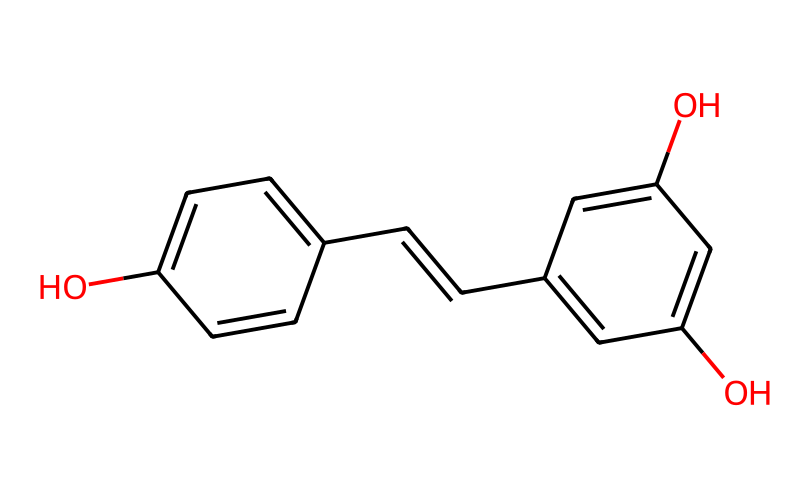What is the chemical name of this compound? The provided SMILES represents a compound known as resveratrol. The first part ("Oc1ccc") indicates the presence of a hydroxyl group (OH), which is characteristic of phenolic compounds like resveratrol.
Answer: resveratrol How many carbon atoms are there in this structure? Analyzing the SMILES, we can count the carbon atoms from the aromatic rings and the alkene chain structure. The first ring contributes six, the second contributes six, and the alkene linkage adds two more carbon atoms, totaling fourteen.
Answer: fourteen What functional groups are present in resveratrol? The SMILES shows two hydroxyl (–OH) groups attached to the aromatic rings, which are phenolic groups. The presence of a double bond (C=C) between two carbon atoms also indicates an alkene functional group.
Answer: hydroxyl and alkene How many rings are there in the molecular structure? The SMILES indicates two aromatic rings (indicated by the "c" in the structure). The branching points and the connections show that these rings are not fused but independently attached.
Answer: two What type of isomerism might resveratrol exhibit due to its structure? The presence of the double bond (C=C) in the structure indicates that resveratrol can exhibit cis-trans isomerism, where the orientation of the substituents across the double bond can vary.
Answer: cis-trans isomerism What characteristic of this compound contributes to its color in red wine? Resveratrol, being a type of phenolic compound, contributes to the color in red wine through its ability to absorb specific wavelengths of light, primarily in the blue and green regions, while reflecting red light.
Answer: phenolic compounds Does this structure contain any chiral centers? A chiral center is typically a carbon atom bonded to four different groups. Analyzing resveratrol’s structure, all carbon atoms are either part of a symmetrical arrangement or bonded to similar atoms, indicating there are no chiral centers.
Answer: no chiral centers 